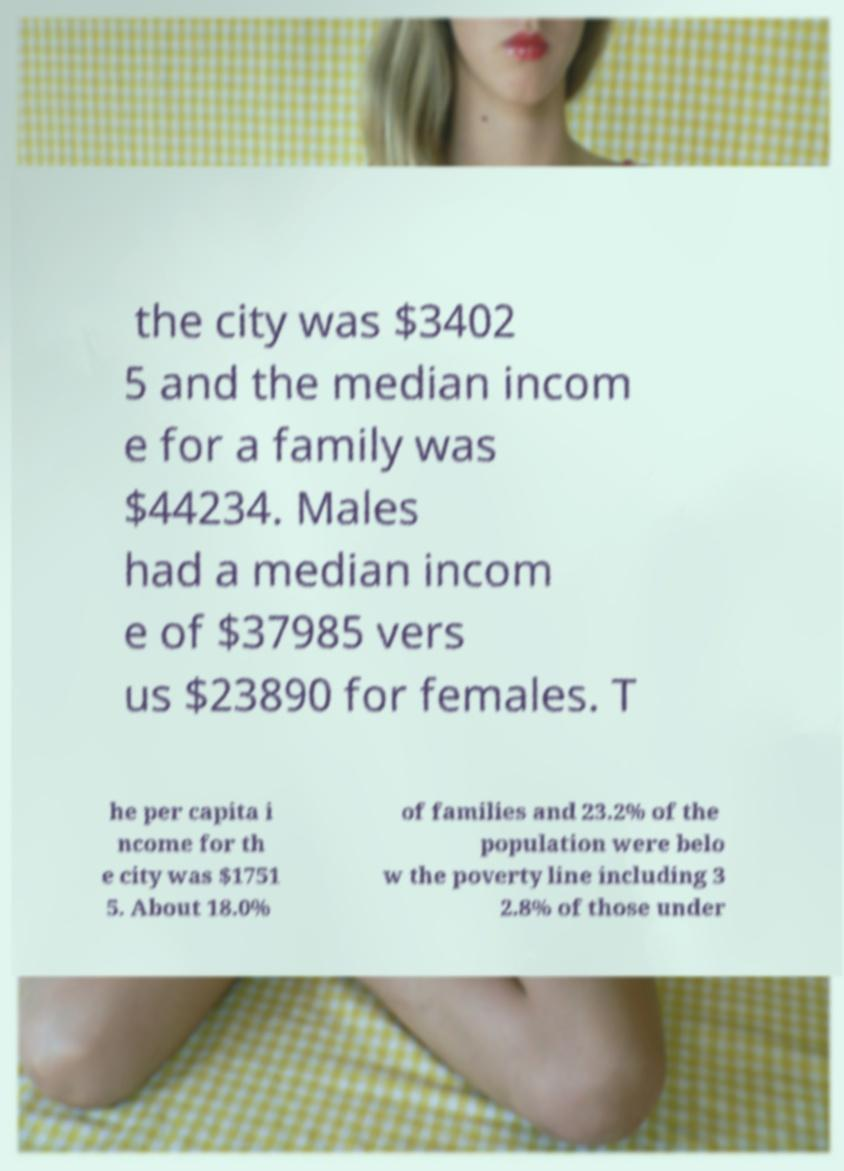What messages or text are displayed in this image? I need them in a readable, typed format. the city was $3402 5 and the median incom e for a family was $44234. Males had a median incom e of $37985 vers us $23890 for females. T he per capita i ncome for th e city was $1751 5. About 18.0% of families and 23.2% of the population were belo w the poverty line including 3 2.8% of those under 